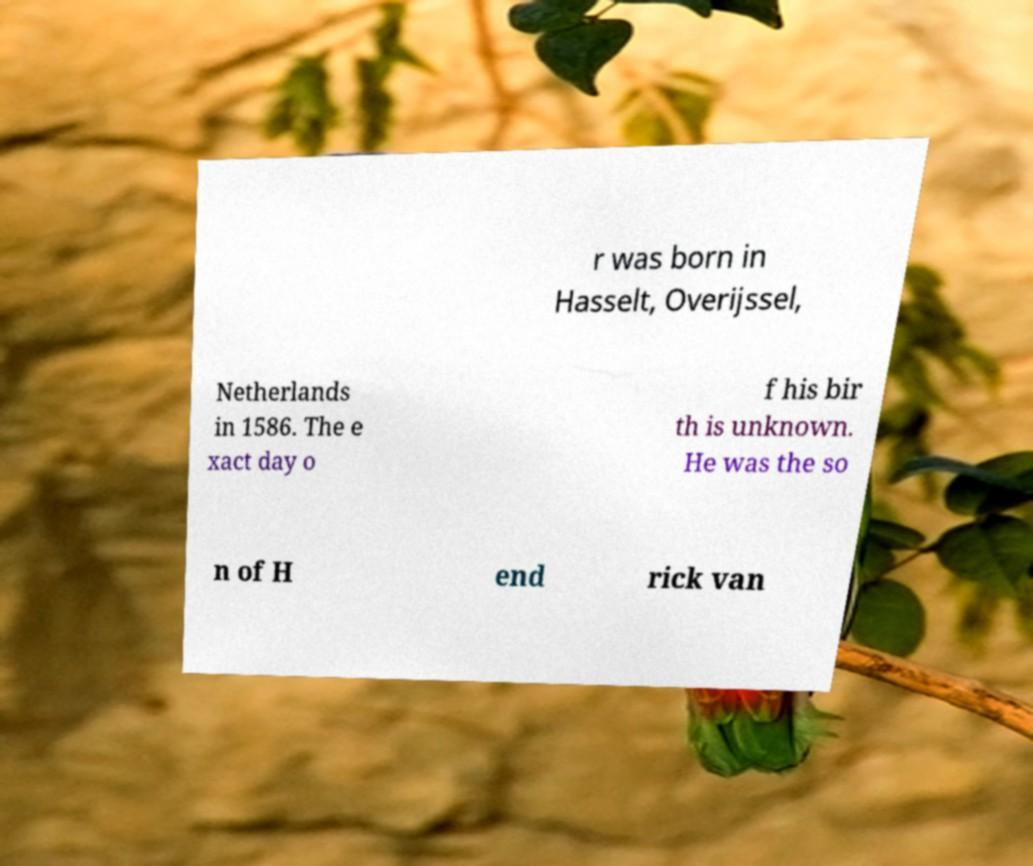I need the written content from this picture converted into text. Can you do that? r was born in Hasselt, Overijssel, Netherlands in 1586. The e xact day o f his bir th is unknown. He was the so n of H end rick van 